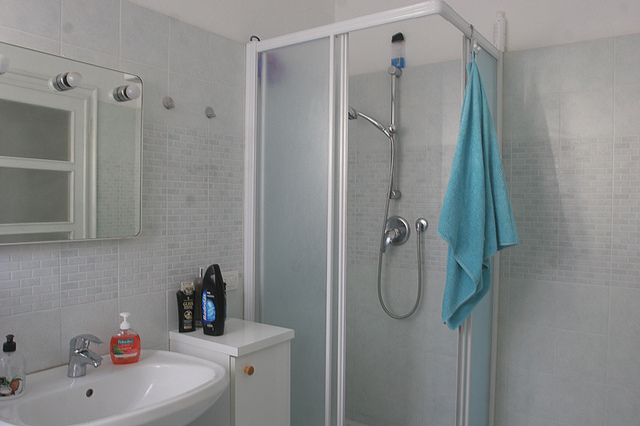What kind of tiles are used in the shower area? The shower area features small, square, matte-finish, light-colored ceramic tiles that cover the walls. 